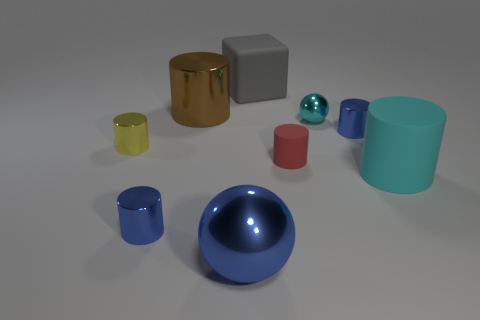Add 6 cyan shiny balls. How many cyan shiny balls are left? 7 Add 1 cyan cubes. How many cyan cubes exist? 1 Subtract all blue balls. How many balls are left? 1 Subtract all tiny blue cylinders. How many cylinders are left? 4 Subtract 2 blue cylinders. How many objects are left? 7 Subtract all cylinders. How many objects are left? 3 Subtract 2 spheres. How many spheres are left? 0 Subtract all green cubes. Subtract all red cylinders. How many cubes are left? 1 Subtract all cyan cubes. How many brown cylinders are left? 1 Subtract all large cubes. Subtract all red cylinders. How many objects are left? 7 